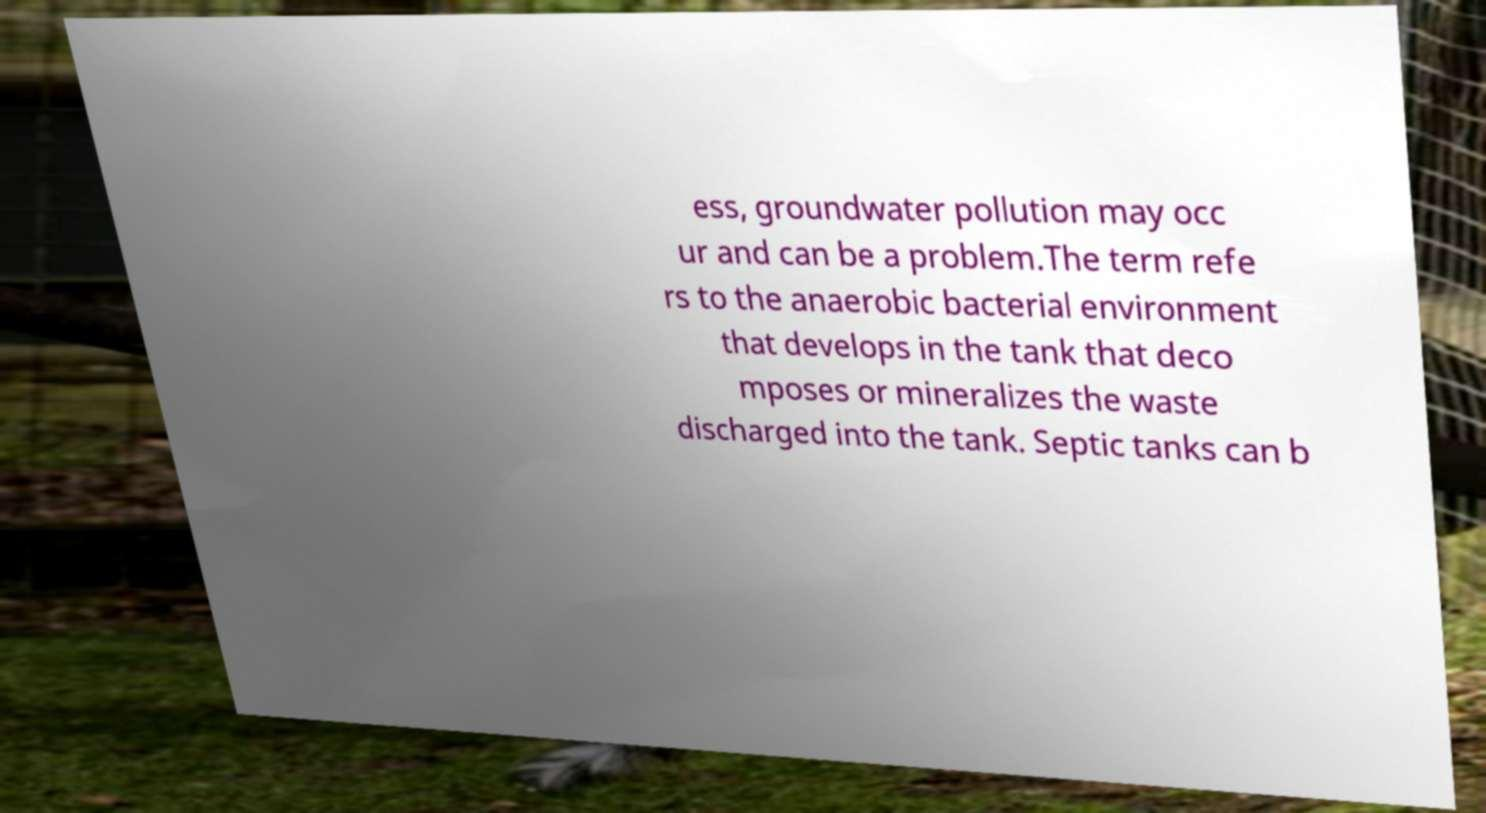There's text embedded in this image that I need extracted. Can you transcribe it verbatim? ess, groundwater pollution may occ ur and can be a problem.The term refe rs to the anaerobic bacterial environment that develops in the tank that deco mposes or mineralizes the waste discharged into the tank. Septic tanks can b 